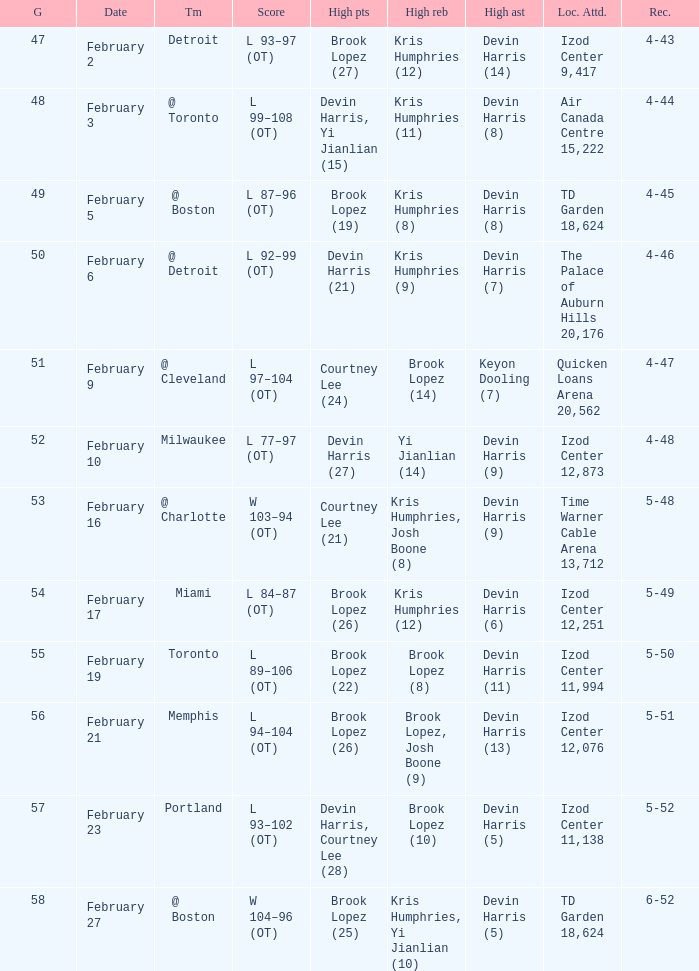Who did the high assists in the game played on February 9? Keyon Dooling (7). 